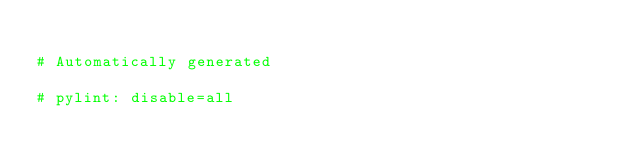<code> <loc_0><loc_0><loc_500><loc_500><_Python_>
# Automatically generated

# pylint: disable=all</code> 